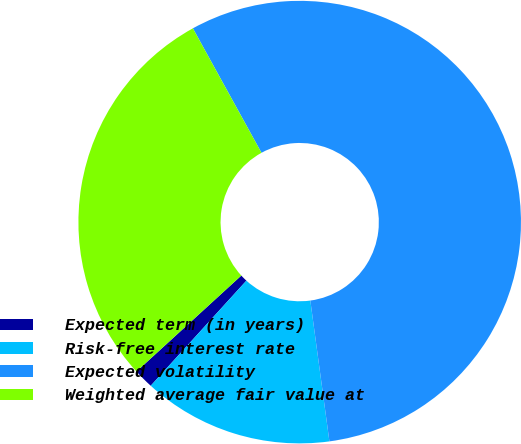<chart> <loc_0><loc_0><loc_500><loc_500><pie_chart><fcel>Expected term (in years)<fcel>Risk-free interest rate<fcel>Expected volatility<fcel>Weighted average fair value at<nl><fcel>1.45%<fcel>13.9%<fcel>55.88%<fcel>28.78%<nl></chart> 